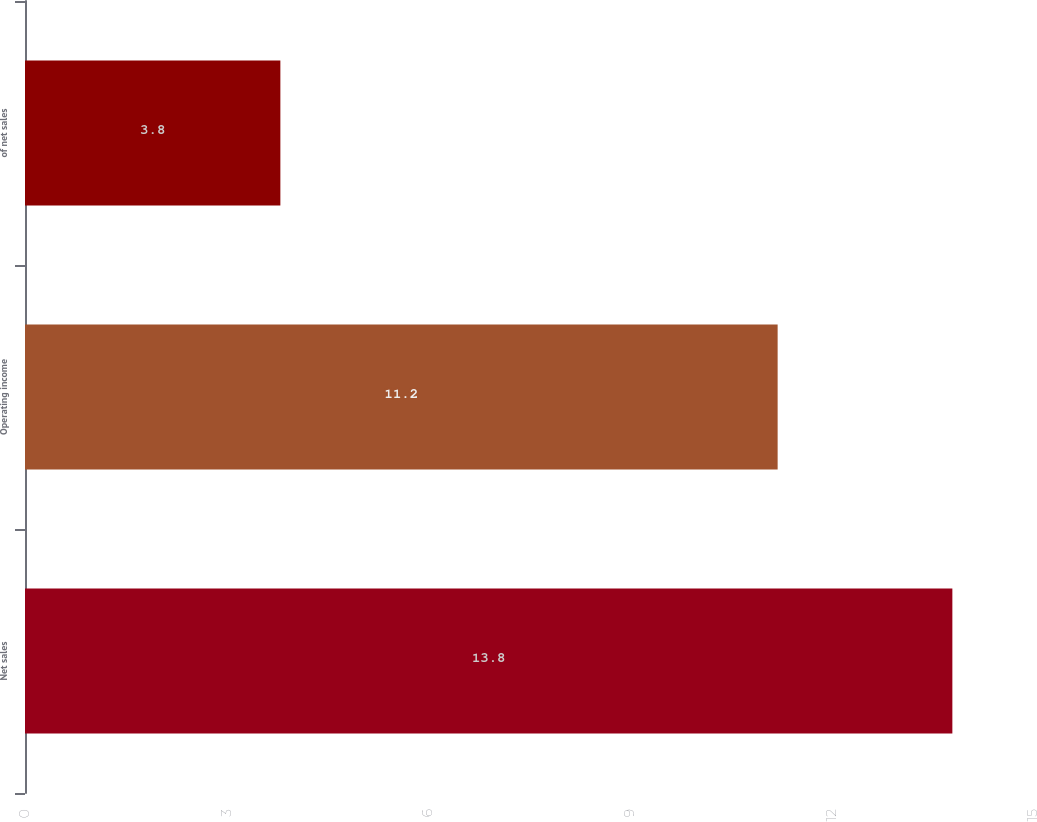Convert chart to OTSL. <chart><loc_0><loc_0><loc_500><loc_500><bar_chart><fcel>Net sales<fcel>Operating income<fcel>of net sales<nl><fcel>13.8<fcel>11.2<fcel>3.8<nl></chart> 